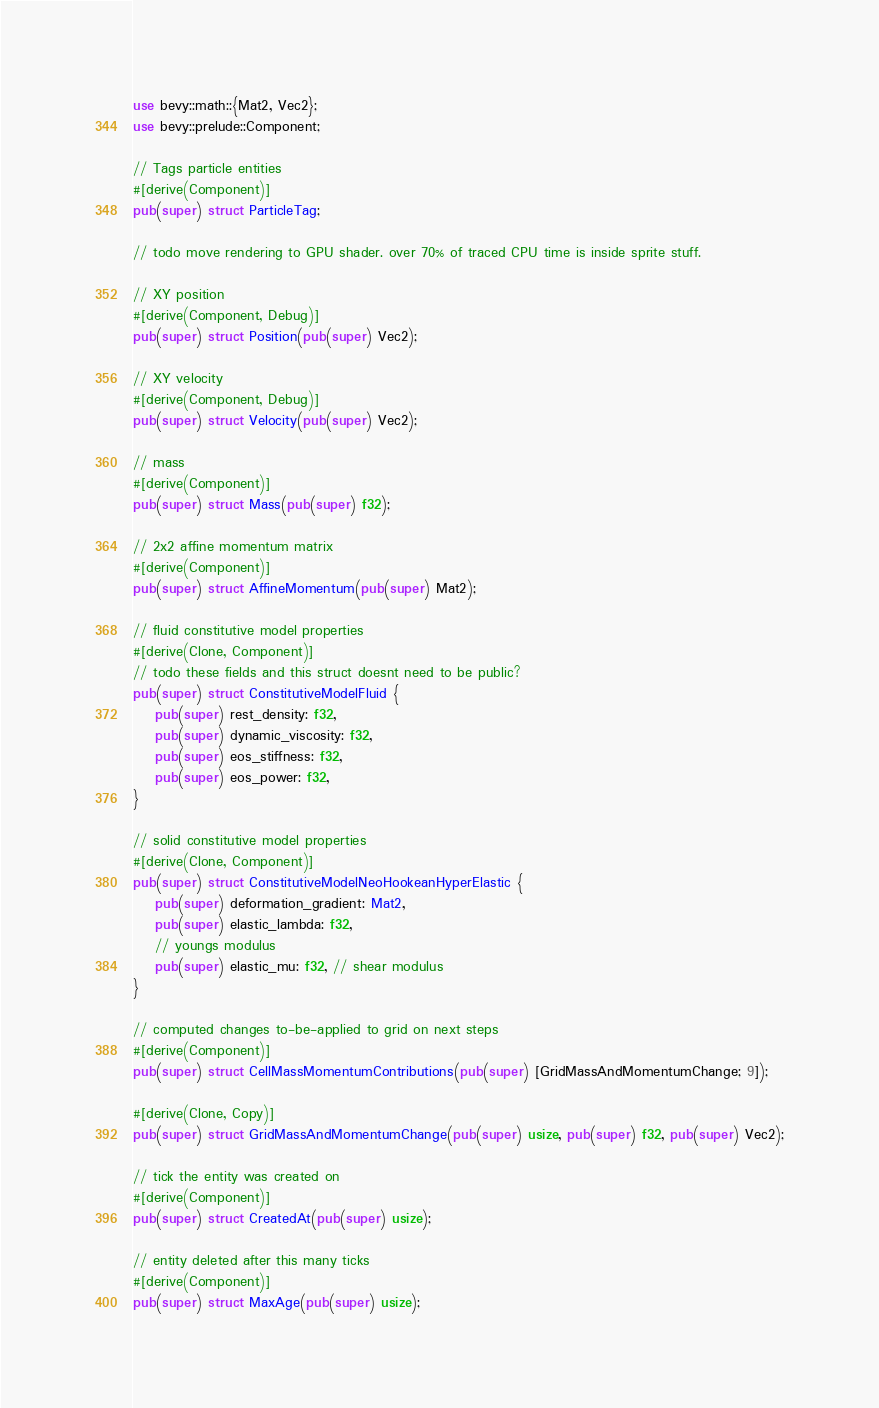Convert code to text. <code><loc_0><loc_0><loc_500><loc_500><_Rust_>use bevy::math::{Mat2, Vec2};
use bevy::prelude::Component;

// Tags particle entities
#[derive(Component)]
pub(super) struct ParticleTag;

// todo move rendering to GPU shader. over 70% of traced CPU time is inside sprite stuff.

// XY position
#[derive(Component, Debug)]
pub(super) struct Position(pub(super) Vec2);

// XY velocity
#[derive(Component, Debug)]
pub(super) struct Velocity(pub(super) Vec2);

// mass
#[derive(Component)]
pub(super) struct Mass(pub(super) f32);

// 2x2 affine momentum matrix
#[derive(Component)]
pub(super) struct AffineMomentum(pub(super) Mat2);

// fluid constitutive model properties
#[derive(Clone, Component)]
// todo these fields and this struct doesnt need to be public?
pub(super) struct ConstitutiveModelFluid {
    pub(super) rest_density: f32,
    pub(super) dynamic_viscosity: f32,
    pub(super) eos_stiffness: f32,
    pub(super) eos_power: f32,
}

// solid constitutive model properties
#[derive(Clone, Component)]
pub(super) struct ConstitutiveModelNeoHookeanHyperElastic {
    pub(super) deformation_gradient: Mat2,
    pub(super) elastic_lambda: f32,
    // youngs modulus
    pub(super) elastic_mu: f32, // shear modulus
}

// computed changes to-be-applied to grid on next steps
#[derive(Component)]
pub(super) struct CellMassMomentumContributions(pub(super) [GridMassAndMomentumChange; 9]);

#[derive(Clone, Copy)]
pub(super) struct GridMassAndMomentumChange(pub(super) usize, pub(super) f32, pub(super) Vec2);

// tick the entity was created on
#[derive(Component)]
pub(super) struct CreatedAt(pub(super) usize);

// entity deleted after this many ticks
#[derive(Component)]
pub(super) struct MaxAge(pub(super) usize);
</code> 